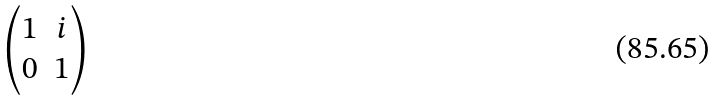<formula> <loc_0><loc_0><loc_500><loc_500>\begin{pmatrix} 1 & i \\ 0 & 1 \end{pmatrix}</formula> 